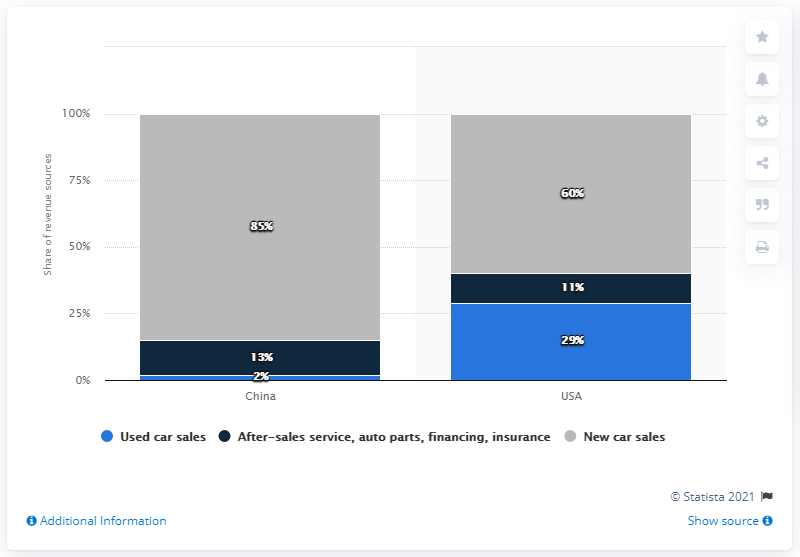Give some essential details in this illustration. The percentage value of used car sales in China is 2%. The percentage value of dealership revenue in the US, besides new car sales, is approximately 40%. 